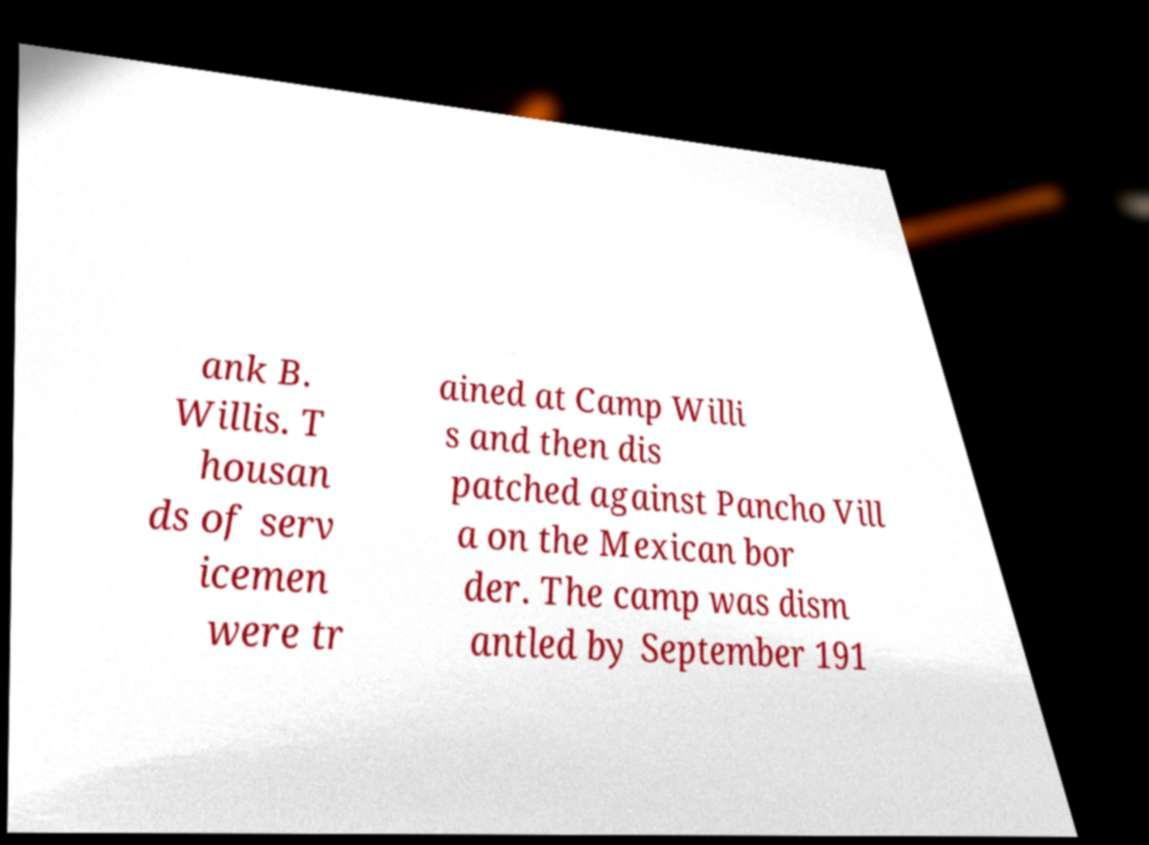Please identify and transcribe the text found in this image. ank B. Willis. T housan ds of serv icemen were tr ained at Camp Willi s and then dis patched against Pancho Vill a on the Mexican bor der. The camp was dism antled by September 191 